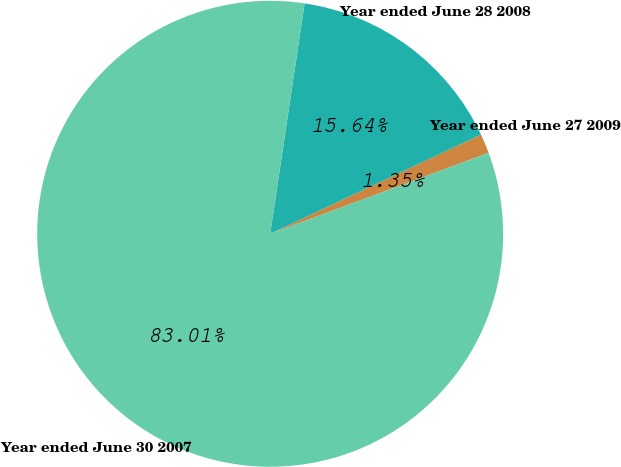<chart> <loc_0><loc_0><loc_500><loc_500><pie_chart><fcel>Year ended June 27 2009<fcel>Year ended June 28 2008<fcel>Year ended June 30 2007<nl><fcel>1.35%<fcel>15.64%<fcel>83.01%<nl></chart> 